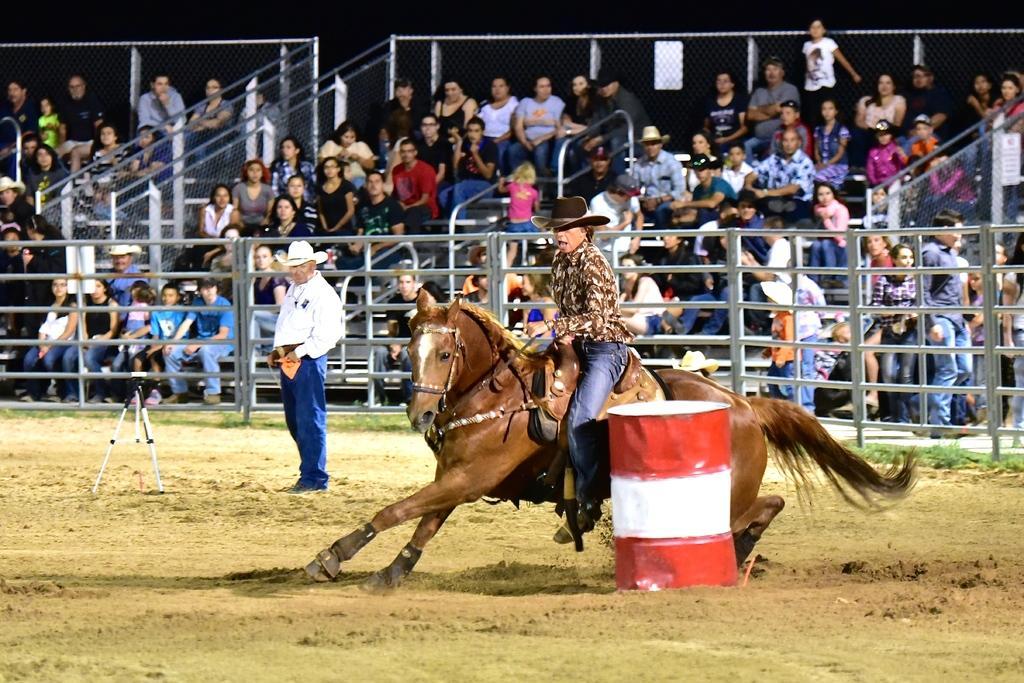Could you give a brief overview of what you see in this image? In this picture there is a man sitting on a horse. There is a barrel. There are few people sitting on the chair. There is a stand and a man is standing. 